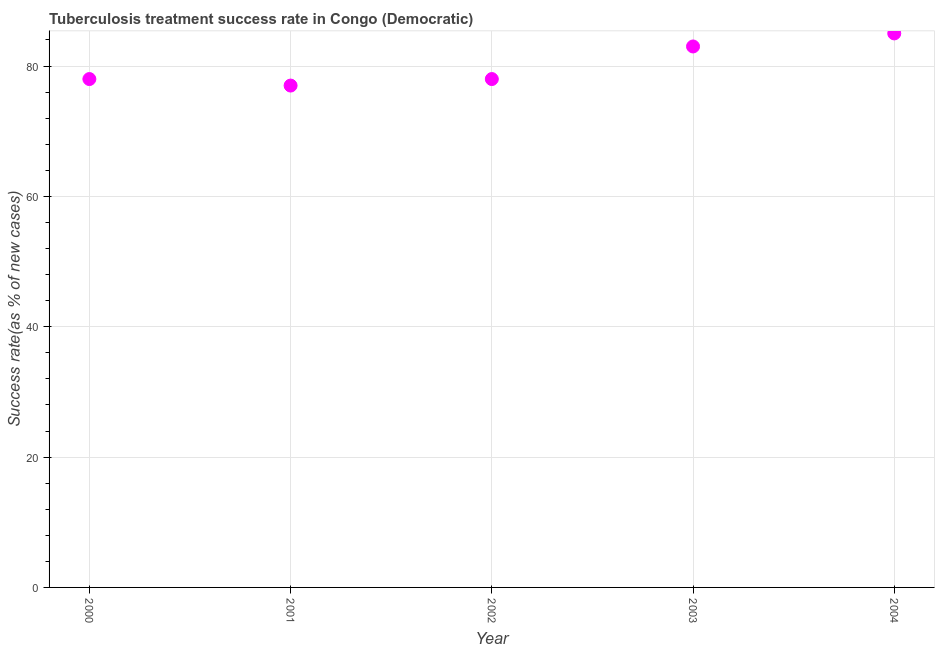What is the tuberculosis treatment success rate in 2000?
Offer a very short reply. 78. Across all years, what is the maximum tuberculosis treatment success rate?
Provide a short and direct response. 85. Across all years, what is the minimum tuberculosis treatment success rate?
Provide a short and direct response. 77. In which year was the tuberculosis treatment success rate maximum?
Provide a succinct answer. 2004. What is the sum of the tuberculosis treatment success rate?
Provide a short and direct response. 401. What is the difference between the tuberculosis treatment success rate in 2000 and 2004?
Give a very brief answer. -7. What is the average tuberculosis treatment success rate per year?
Your answer should be compact. 80.2. Do a majority of the years between 2000 and 2002 (inclusive) have tuberculosis treatment success rate greater than 80 %?
Keep it short and to the point. No. What is the ratio of the tuberculosis treatment success rate in 2001 to that in 2002?
Keep it short and to the point. 0.99. Is the tuberculosis treatment success rate in 2000 less than that in 2002?
Your response must be concise. No. Is the difference between the tuberculosis treatment success rate in 2000 and 2003 greater than the difference between any two years?
Keep it short and to the point. No. What is the difference between the highest and the second highest tuberculosis treatment success rate?
Keep it short and to the point. 2. What is the difference between the highest and the lowest tuberculosis treatment success rate?
Offer a very short reply. 8. In how many years, is the tuberculosis treatment success rate greater than the average tuberculosis treatment success rate taken over all years?
Make the answer very short. 2. How many dotlines are there?
Keep it short and to the point. 1. Are the values on the major ticks of Y-axis written in scientific E-notation?
Offer a terse response. No. Does the graph contain any zero values?
Offer a terse response. No. What is the title of the graph?
Offer a very short reply. Tuberculosis treatment success rate in Congo (Democratic). What is the label or title of the X-axis?
Make the answer very short. Year. What is the label or title of the Y-axis?
Give a very brief answer. Success rate(as % of new cases). What is the Success rate(as % of new cases) in 2001?
Your response must be concise. 77. What is the Success rate(as % of new cases) in 2004?
Your answer should be very brief. 85. What is the difference between the Success rate(as % of new cases) in 2000 and 2002?
Your response must be concise. 0. What is the difference between the Success rate(as % of new cases) in 2001 and 2002?
Your response must be concise. -1. What is the difference between the Success rate(as % of new cases) in 2001 and 2003?
Your response must be concise. -6. What is the difference between the Success rate(as % of new cases) in 2002 and 2003?
Keep it short and to the point. -5. What is the ratio of the Success rate(as % of new cases) in 2000 to that in 2001?
Give a very brief answer. 1.01. What is the ratio of the Success rate(as % of new cases) in 2000 to that in 2003?
Make the answer very short. 0.94. What is the ratio of the Success rate(as % of new cases) in 2000 to that in 2004?
Make the answer very short. 0.92. What is the ratio of the Success rate(as % of new cases) in 2001 to that in 2002?
Provide a short and direct response. 0.99. What is the ratio of the Success rate(as % of new cases) in 2001 to that in 2003?
Make the answer very short. 0.93. What is the ratio of the Success rate(as % of new cases) in 2001 to that in 2004?
Offer a terse response. 0.91. What is the ratio of the Success rate(as % of new cases) in 2002 to that in 2004?
Offer a very short reply. 0.92. 